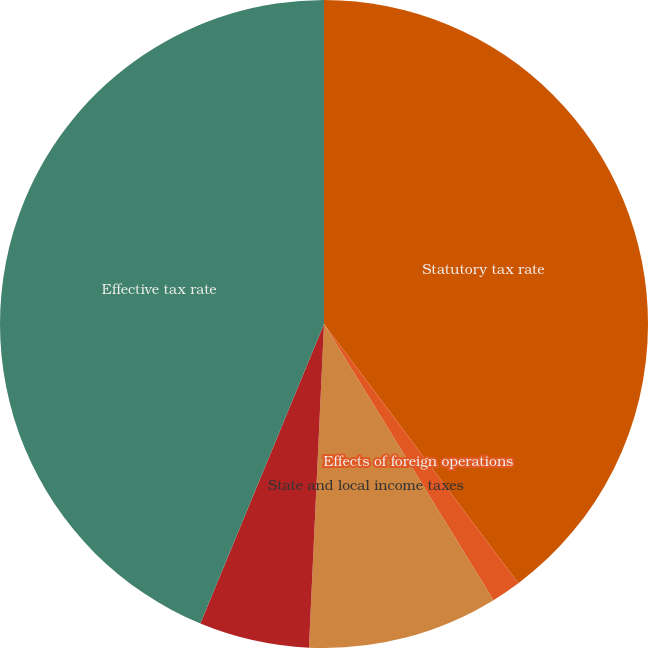<chart> <loc_0><loc_0><loc_500><loc_500><pie_chart><fcel>Statutory tax rate<fcel>Effects of foreign operations<fcel>State and local income taxes<fcel>Other federal tax effects<fcel>Effective tax rate<nl><fcel>39.76%<fcel>1.48%<fcel>9.5%<fcel>5.49%<fcel>43.77%<nl></chart> 